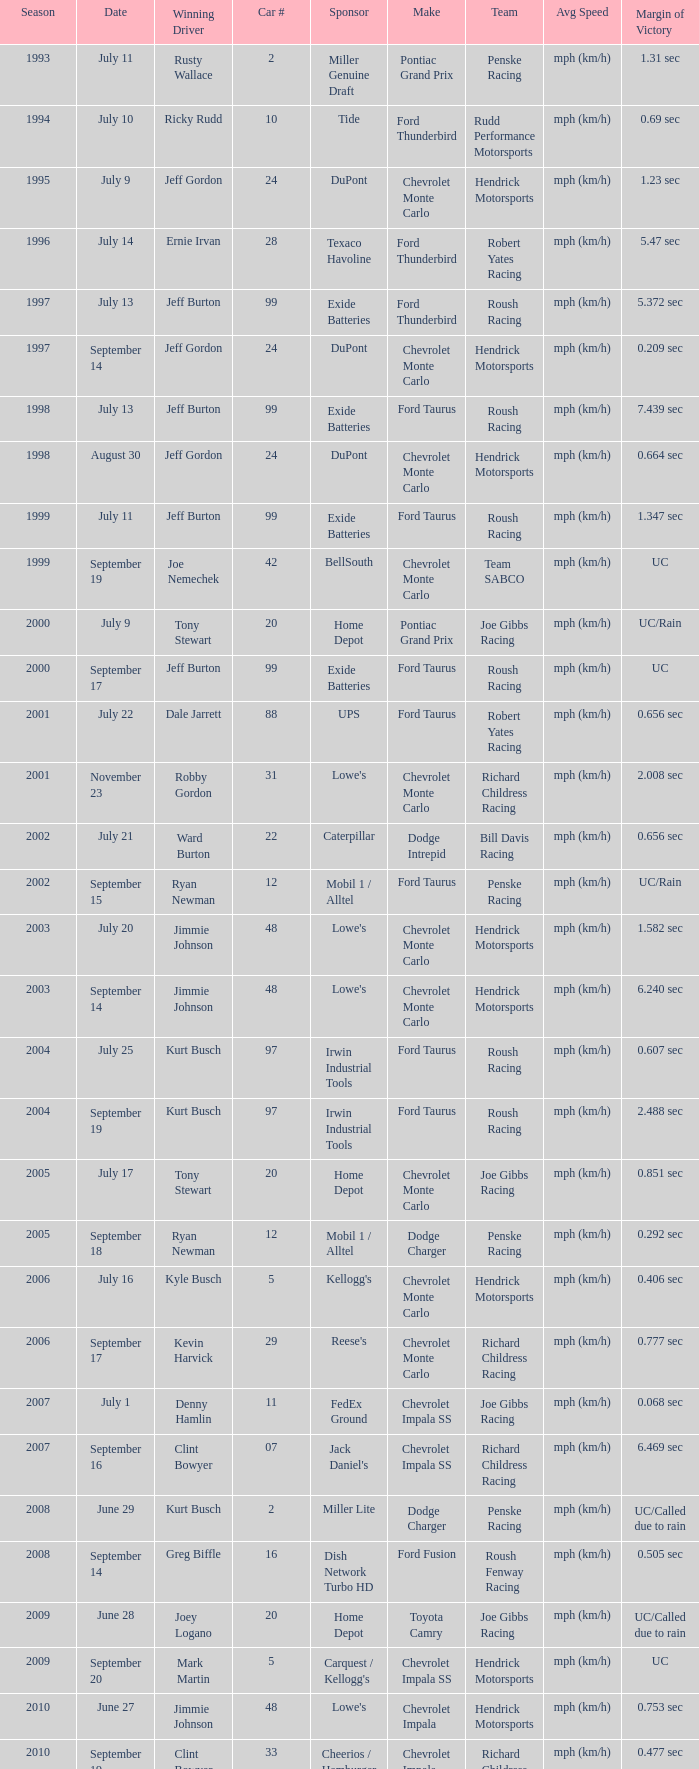What was the average speed of Tony Stewart's winning Chevrolet Impala? Mph (km/h). 